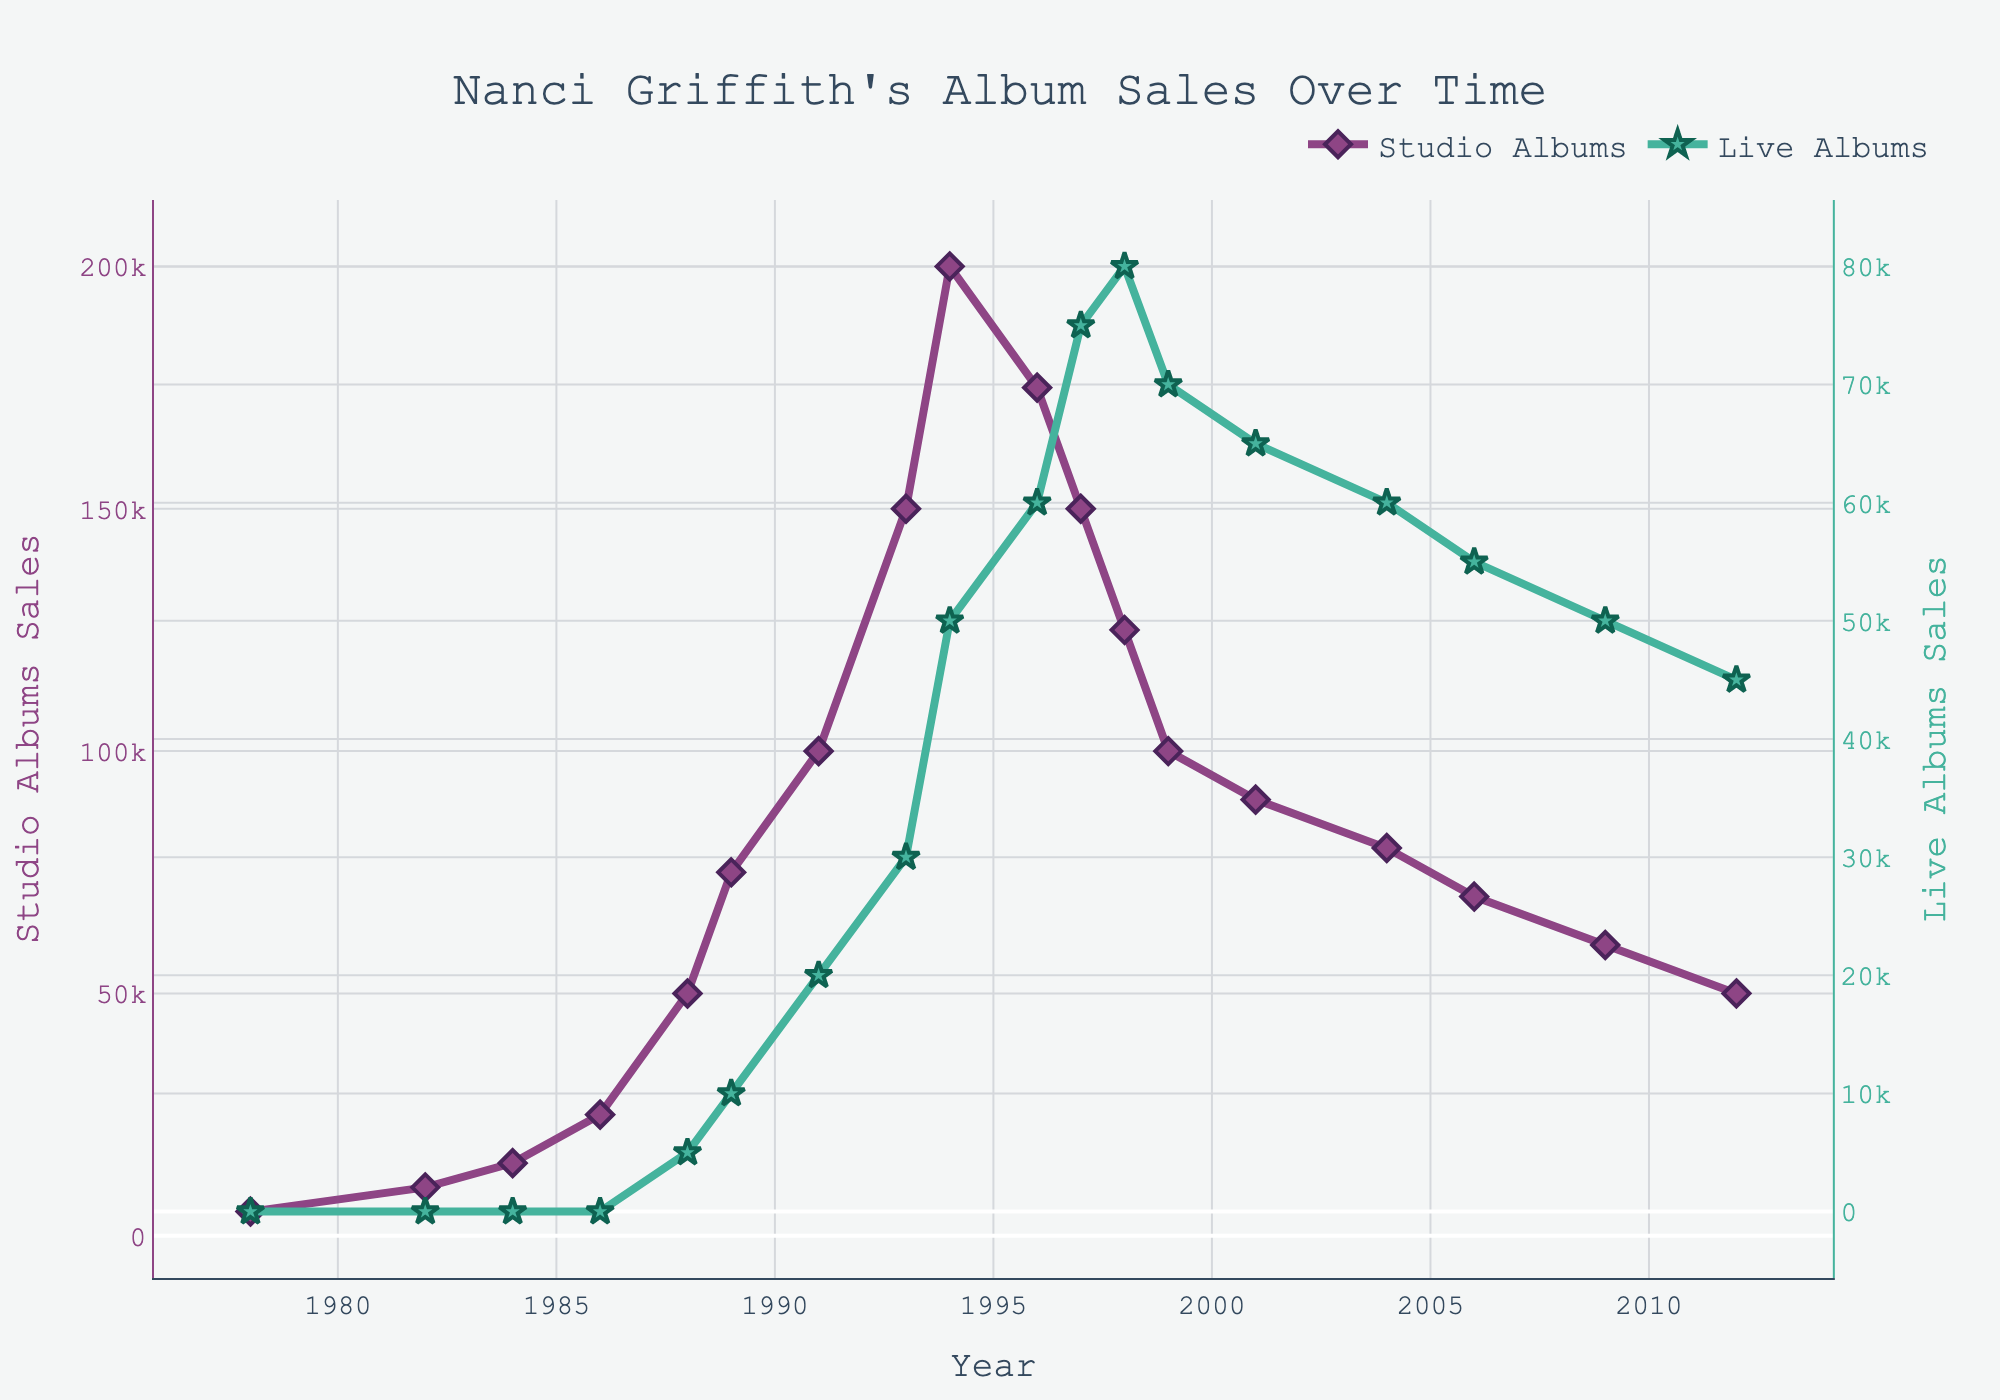When did Nanci Griffith's studio album sales peak? The line chart shows that Nanci Griffith's studio album sales were highest around 1994. This can be seen as the tallest point on the line representing studio albums.
Answer: 1994 Which year had the highest sales for live albums, and what were the sales figures at that year? To find the highest sales for live albums, look for the peak point on the line representing live albums. The live albums sales peaked in 1998 with sales of 80,000.
Answer: 1998, 80,000 What is the difference in studio album sales between 1994 and 2004? To find the difference, first identify the studio album sales for 1994 (200,000) and for 2004 (80,000). Subtract the latter from the former: 200,000 - 80,000 = 120,000.
Answer: 120,000 How many years did it take for the studio album sales to increase from 25,000 to 100,000? Find the year when studio album sales were 25,000 (1986) and the year when they reached 100,000 (1991). Subtract the earlier year from the latter: 1991 - 1986 = 5 years.
Answer: 5 years Compare the trend of studio album sales and live album sales from 1996 to 2004. Which one decreased more significantly? Look at the lines from 1996 to 2004. Studio album sales dropped from 175,000 to 80,000 (a decrease of 95,000). Live album sales dropped from 60,000 to 60,000 (no significant change). Hence, studio album sales had a more significant decrease.
Answer: Studio albums What is the average sales for studio albums over the period 1978 to 2012? Sum the studio album sales for each year and divide by the number of years (16 years). The sum is 1,290,000, so the average is 1,290,000 / 16.
Answer: 80,625 What is the ratio of live album sales to studio album sales in 1997? Identify the sales for 1997: studio albums (150,000) and live albums (75,000). The ratio is 75,000 / 150,000, which simplifies to 1:2.
Answer: 1:2 Between which consecutive years did the studio album sales increase the most? Observe the points for each consecutive year and calculate the differences. The greatest increase is between 1993 (150,000) and 1994 (200,000), a difference of 50,000.
Answer: 1993 to 1994 What are the total sales (studio and live albums combined) in 1999? Sum the sales for studio albums (100,000) and live albums (70,000) for 1999: 100,000 + 70,000 = 170,000.
Answer: 170,000 Which album type, studio or live, maintained a more consistent sales trend over the years? Observe both lines. Live album sales show a slower, more consistent trend, without sharp peaks or drops compared to studio albums.
Answer: Live albums 